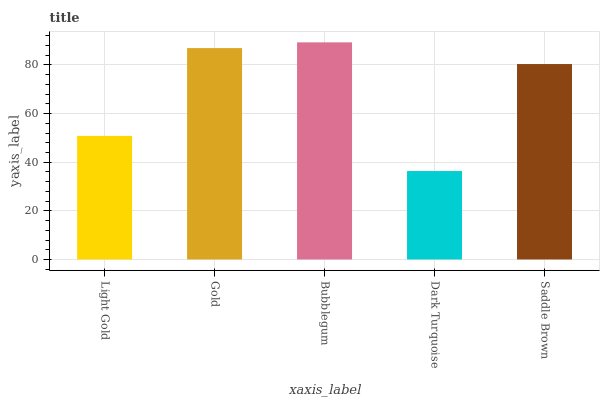Is Dark Turquoise the minimum?
Answer yes or no. Yes. Is Bubblegum the maximum?
Answer yes or no. Yes. Is Gold the minimum?
Answer yes or no. No. Is Gold the maximum?
Answer yes or no. No. Is Gold greater than Light Gold?
Answer yes or no. Yes. Is Light Gold less than Gold?
Answer yes or no. Yes. Is Light Gold greater than Gold?
Answer yes or no. No. Is Gold less than Light Gold?
Answer yes or no. No. Is Saddle Brown the high median?
Answer yes or no. Yes. Is Saddle Brown the low median?
Answer yes or no. Yes. Is Dark Turquoise the high median?
Answer yes or no. No. Is Bubblegum the low median?
Answer yes or no. No. 